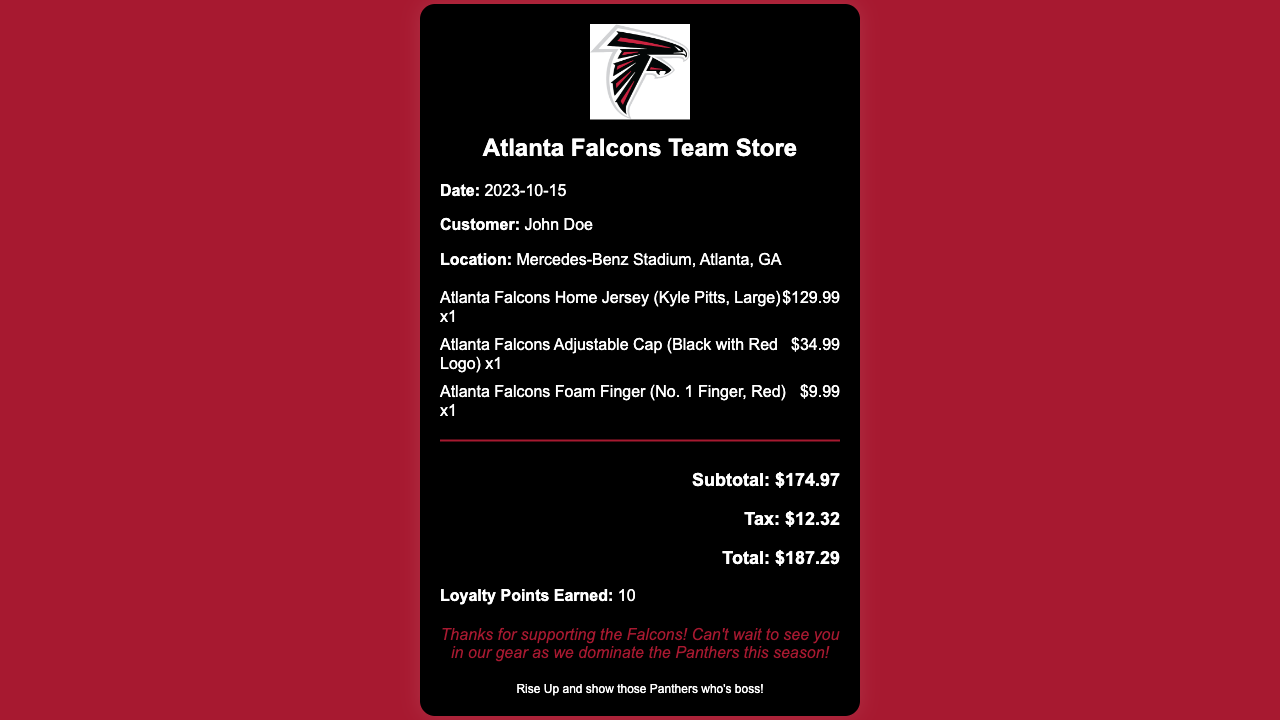What is the date of the receipt? The date is explicitly stated in the receipt under the date section.
Answer: 2023-10-15 What is the name of the customer? The customer's name is mentioned in the receipt details section.
Answer: John Doe What is the total amount paid? The total amount is clearly listed in the total section of the receipt.
Answer: $187.29 How many loyalty points were earned? The loyalty points earned are noted at the bottom of the receipt.
Answer: 10 What is the price of the Atlanta Falcons Home Jersey? The price of the jersey is shown next to the item description in the items section.
Answer: $129.99 What type of cap was purchased? The specific type of cap purchased is detailed in the items section of the receipt.
Answer: Adjustable Cap (Black with Red Logo) Which player’s jersey is featured in the receipt? The jersey description mentions the player's name in parentheses.
Answer: Kyle Pitts What color is the foam finger? The description of the foam finger is included in the items section.
Answer: Red What is the subtotal before tax? The subtotal is listed in the total section prior to the tax amount.
Answer: $174.97 